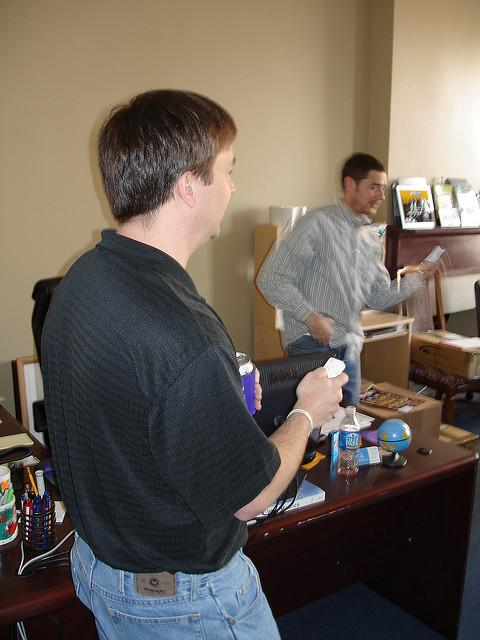What is the blue round object sitting on the desk a model of? globe 